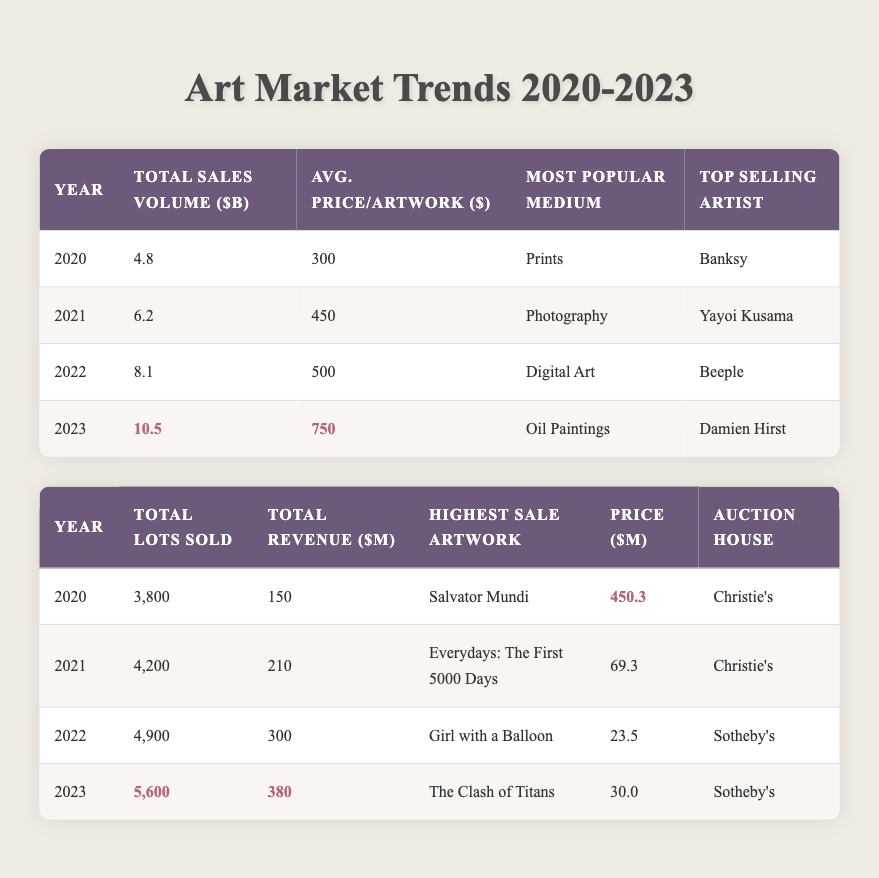What was the total sales volume in 2021? The table indicates that the total sales volume for the year 2021 is listed directly under the "Total Sales Volume" column, which is 6.2 billion dollars.
Answer: 6.2 billion Which year saw the highest average price per artwork? By examining the "Avg. Price/Artwork" column, we find that 2023 has the highest value of 750 dollars, compared to other years where the values were lower (500 in 2022, 450 in 2021, and 300 in 2020).
Answer: 2023 How many total lots were sold across all years? Adding up the "Total Lots Sold" values from each year: 3800 (2020) + 4200 (2021) + 4900 (2022) + 5600 (2023) equals a total of 18500 lots sold over the four years.
Answer: 18500 Was the top selling artist in 2022 different from that in 2023? In 2022, the top selling artist was Beeple, while in 2023 it was Damien Hirst. Since these two names are different, the answer is yes.
Answer: Yes What was the percentage increase in total sales volume from 2022 to 2023? To calculate this percentage increase, we first find the difference between the two years: 10.5 (2023) - 8.1 (2022) equals 2.4. Then, we divide this difference by 8.1 (the total for 2022), getting approximately 0.296. Finally, we multiply by 100 to convert to a percentage, which gives around 29.6%.
Answer: 29.6% 